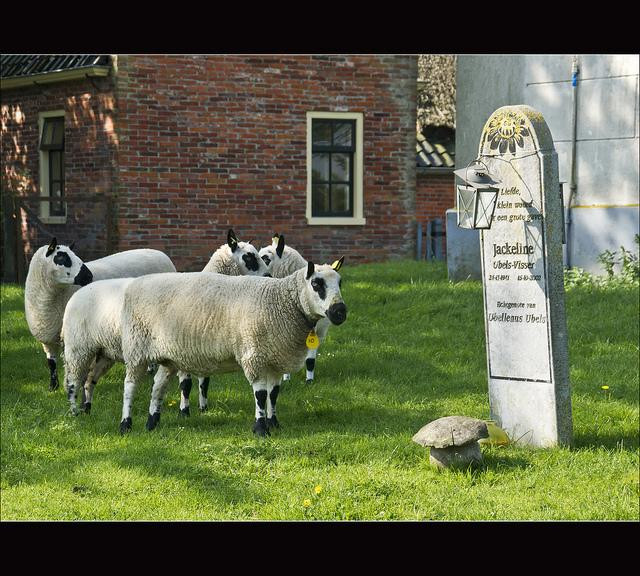What color are the patches around the eyes and noses of the sheep in this field? black 